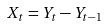Convert formula to latex. <formula><loc_0><loc_0><loc_500><loc_500>X _ { t } = Y _ { t } - Y _ { t - 1 }</formula> 